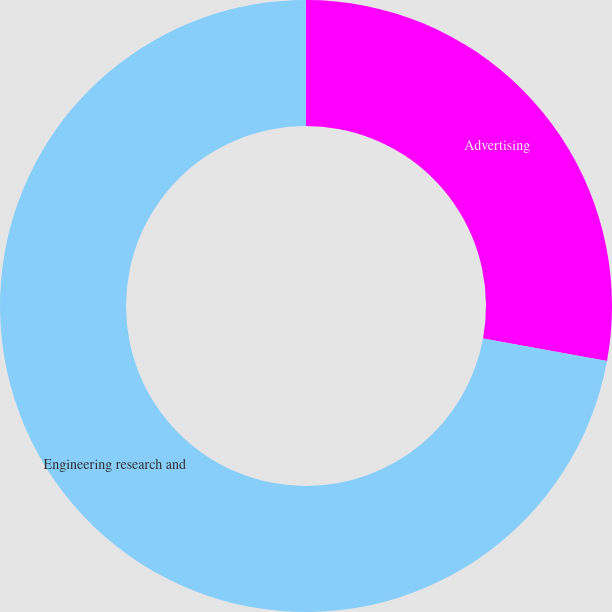Convert chart. <chart><loc_0><loc_0><loc_500><loc_500><pie_chart><fcel>Advertising<fcel>Engineering research and<nl><fcel>27.88%<fcel>72.12%<nl></chart> 